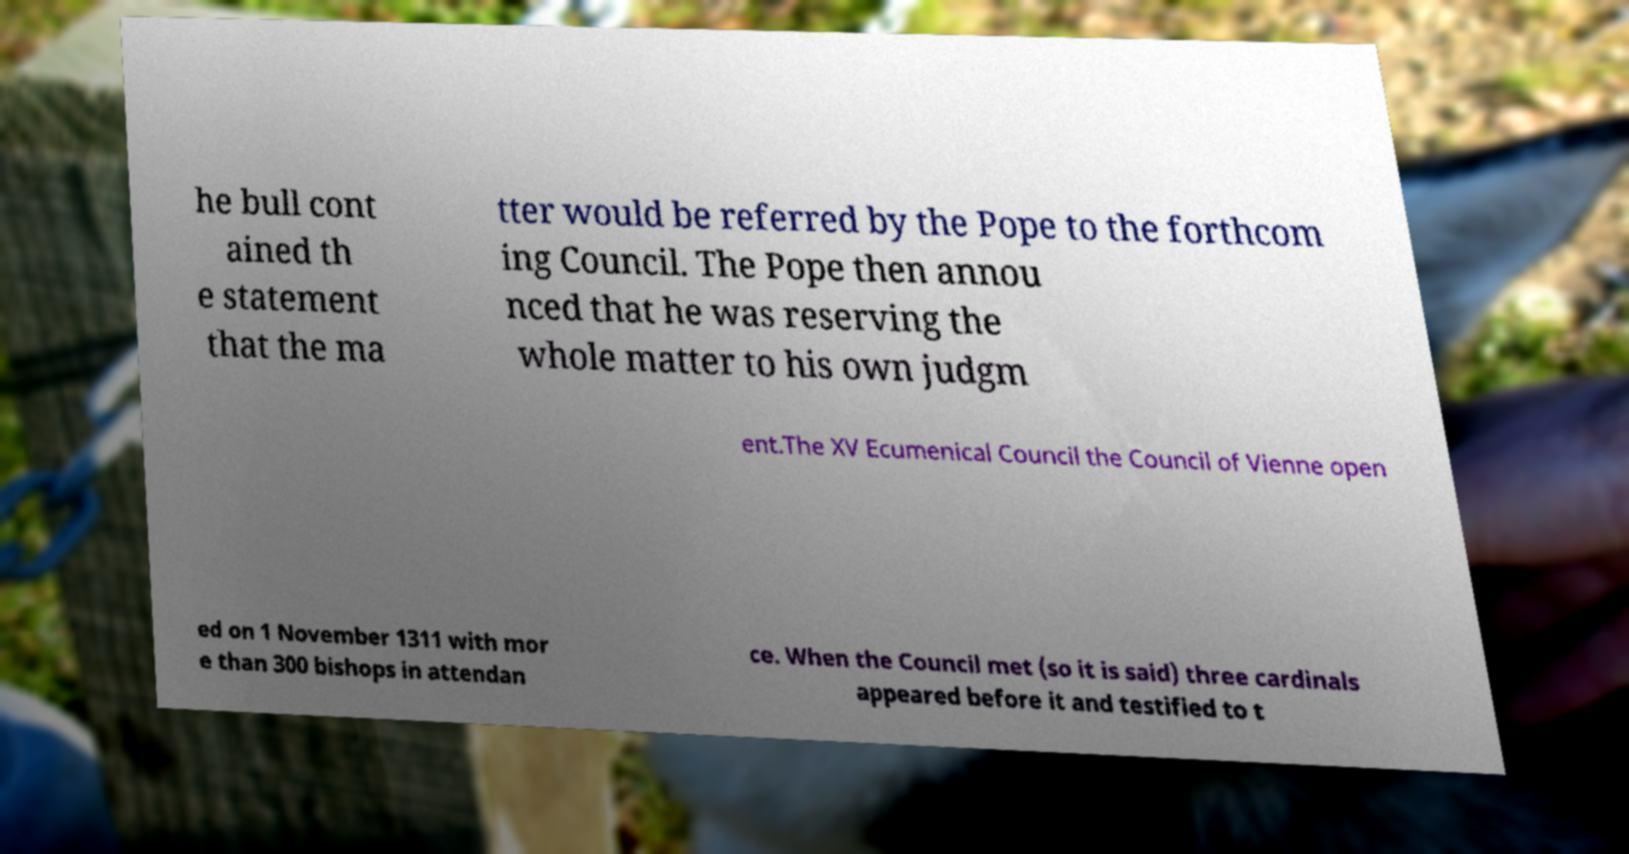Can you accurately transcribe the text from the provided image for me? he bull cont ained th e statement that the ma tter would be referred by the Pope to the forthcom ing Council. The Pope then annou nced that he was reserving the whole matter to his own judgm ent.The XV Ecumenical Council the Council of Vienne open ed on 1 November 1311 with mor e than 300 bishops in attendan ce. When the Council met (so it is said) three cardinals appeared before it and testified to t 